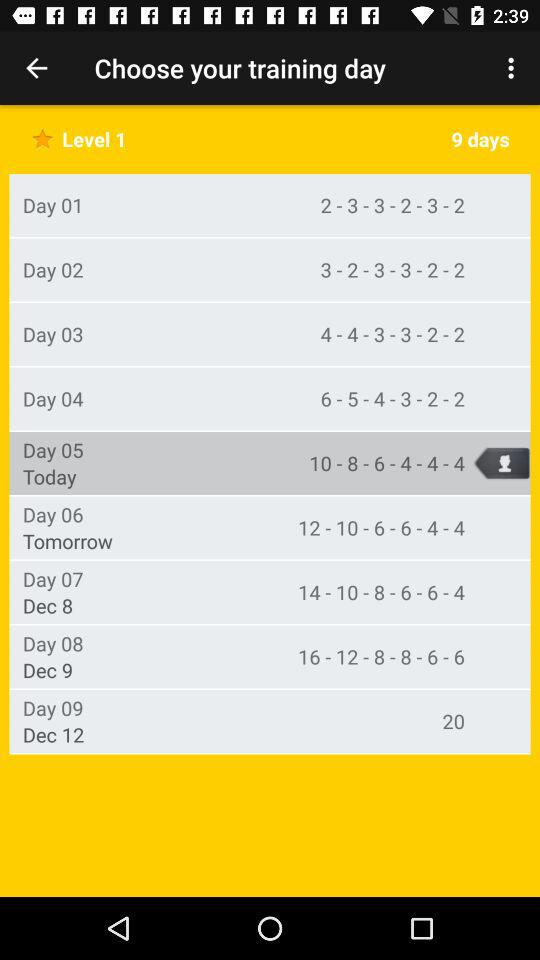How many days of training are there in level 1? There are 9 days of training in level 1. 